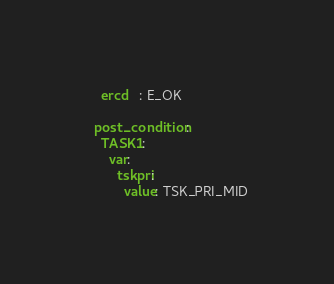<code> <loc_0><loc_0><loc_500><loc_500><_YAML_>    ercd   : E_OK

  post_condition:
    TASK1:
      var:
        tskpri:
          value: TSK_PRI_MID
</code> 